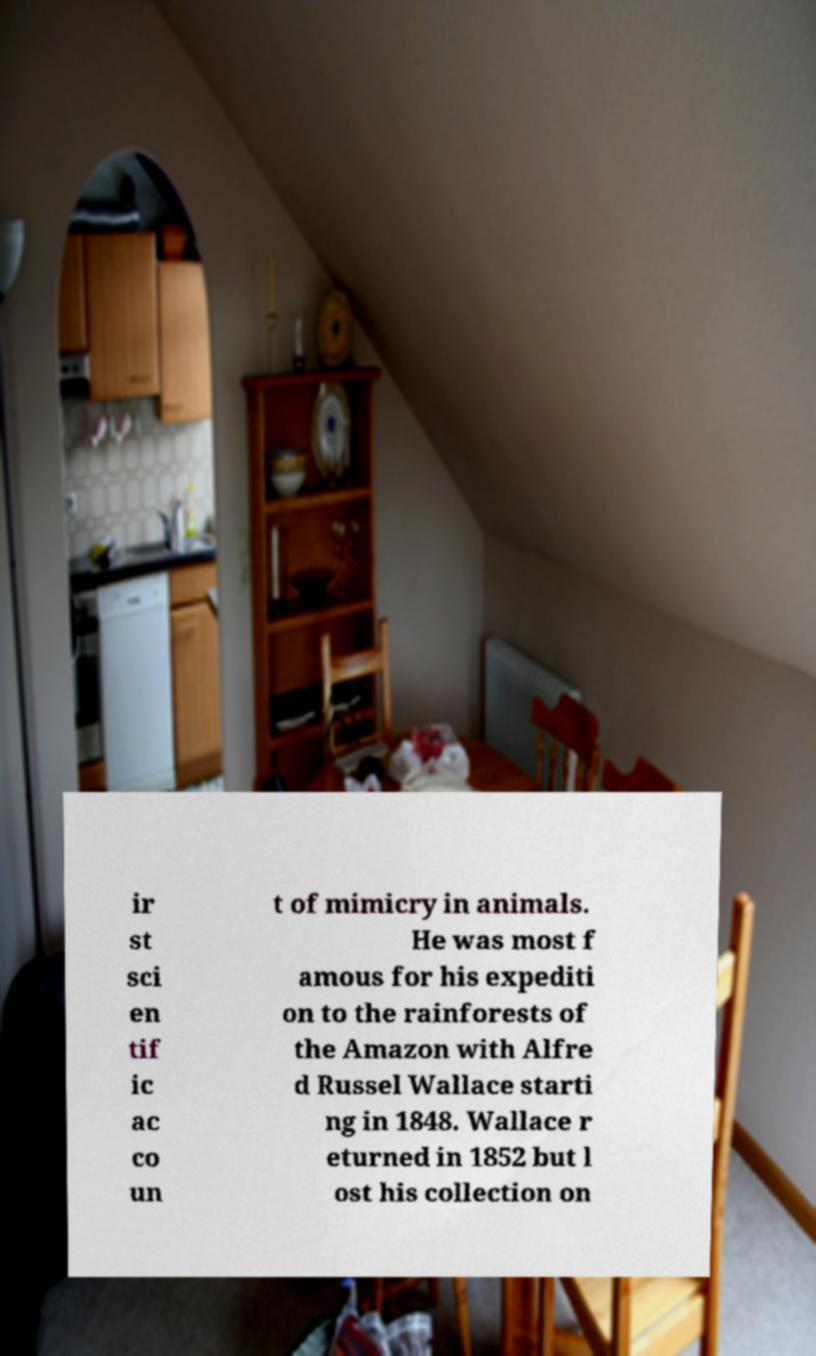I need the written content from this picture converted into text. Can you do that? ir st sci en tif ic ac co un t of mimicry in animals. He was most f amous for his expediti on to the rainforests of the Amazon with Alfre d Russel Wallace starti ng in 1848. Wallace r eturned in 1852 but l ost his collection on 